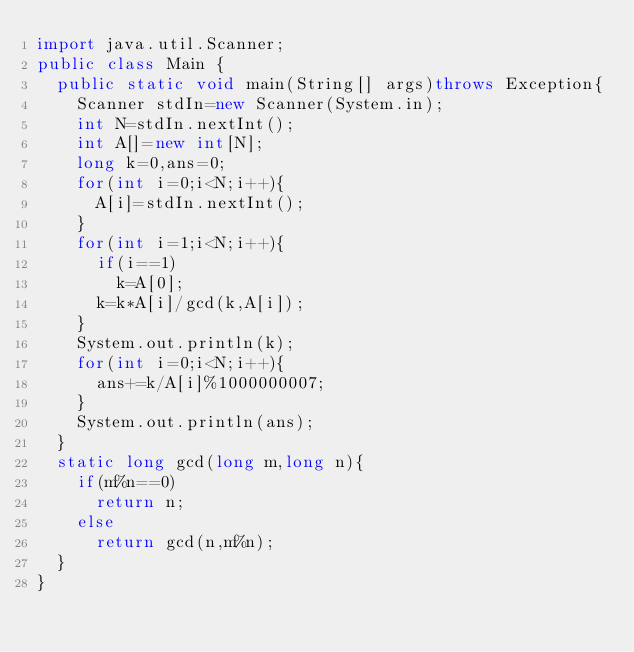Convert code to text. <code><loc_0><loc_0><loc_500><loc_500><_Java_>import java.util.Scanner;
public class Main {
	public static void main(String[] args)throws Exception{
		Scanner stdIn=new Scanner(System.in);
		int N=stdIn.nextInt();
		int A[]=new int[N];
		long k=0,ans=0;
		for(int i=0;i<N;i++){
			A[i]=stdIn.nextInt();
		}
		for(int i=1;i<N;i++){
			if(i==1)
				k=A[0];
			k=k*A[i]/gcd(k,A[i]);
		}
		System.out.println(k);
		for(int i=0;i<N;i++){
			ans+=k/A[i]%1000000007;
		}
		System.out.println(ans);
	}
	static long gcd(long m,long n){
		if(m%n==0)
			return n;
		else
			return gcd(n,m%n);
	}
}
</code> 